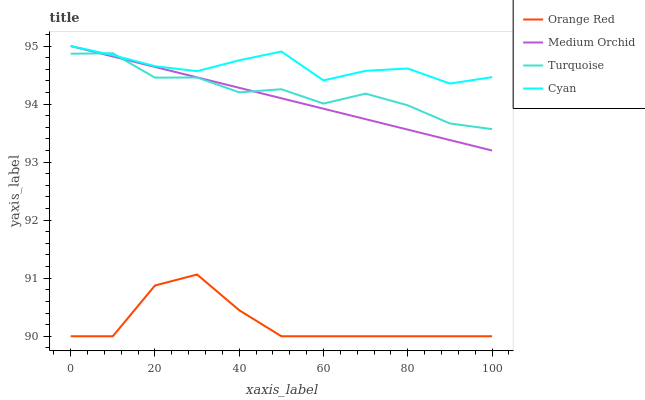Does Orange Red have the minimum area under the curve?
Answer yes or no. Yes. Does Cyan have the maximum area under the curve?
Answer yes or no. Yes. Does Turquoise have the minimum area under the curve?
Answer yes or no. No. Does Turquoise have the maximum area under the curve?
Answer yes or no. No. Is Medium Orchid the smoothest?
Answer yes or no. Yes. Is Orange Red the roughest?
Answer yes or no. Yes. Is Turquoise the smoothest?
Answer yes or no. No. Is Turquoise the roughest?
Answer yes or no. No. Does Orange Red have the lowest value?
Answer yes or no. Yes. Does Turquoise have the lowest value?
Answer yes or no. No. Does Medium Orchid have the highest value?
Answer yes or no. Yes. Does Turquoise have the highest value?
Answer yes or no. No. Is Orange Red less than Turquoise?
Answer yes or no. Yes. Is Turquoise greater than Orange Red?
Answer yes or no. Yes. Does Turquoise intersect Cyan?
Answer yes or no. Yes. Is Turquoise less than Cyan?
Answer yes or no. No. Is Turquoise greater than Cyan?
Answer yes or no. No. Does Orange Red intersect Turquoise?
Answer yes or no. No. 